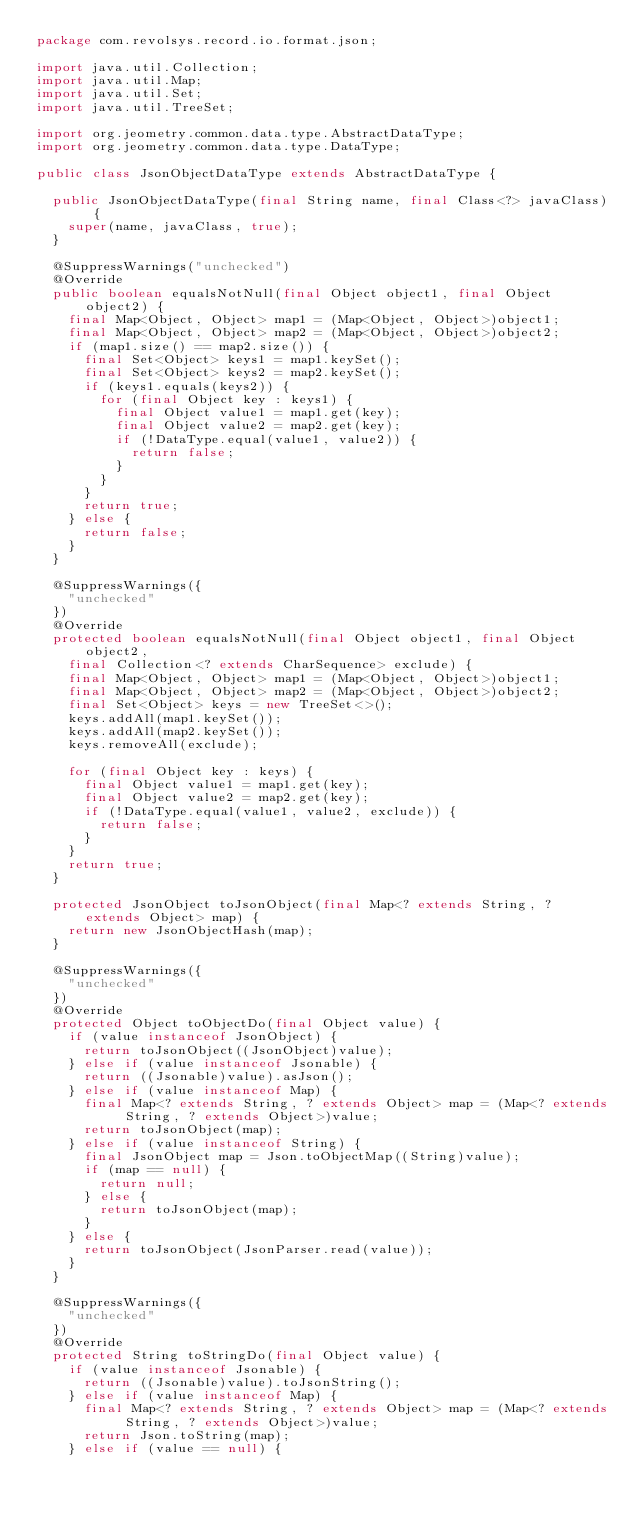Convert code to text. <code><loc_0><loc_0><loc_500><loc_500><_Java_>package com.revolsys.record.io.format.json;

import java.util.Collection;
import java.util.Map;
import java.util.Set;
import java.util.TreeSet;

import org.jeometry.common.data.type.AbstractDataType;
import org.jeometry.common.data.type.DataType;

public class JsonObjectDataType extends AbstractDataType {

  public JsonObjectDataType(final String name, final Class<?> javaClass) {
    super(name, javaClass, true);
  }

  @SuppressWarnings("unchecked")
  @Override
  public boolean equalsNotNull(final Object object1, final Object object2) {
    final Map<Object, Object> map1 = (Map<Object, Object>)object1;
    final Map<Object, Object> map2 = (Map<Object, Object>)object2;
    if (map1.size() == map2.size()) {
      final Set<Object> keys1 = map1.keySet();
      final Set<Object> keys2 = map2.keySet();
      if (keys1.equals(keys2)) {
        for (final Object key : keys1) {
          final Object value1 = map1.get(key);
          final Object value2 = map2.get(key);
          if (!DataType.equal(value1, value2)) {
            return false;
          }
        }
      }
      return true;
    } else {
      return false;
    }
  }

  @SuppressWarnings({
    "unchecked"
  })
  @Override
  protected boolean equalsNotNull(final Object object1, final Object object2,
    final Collection<? extends CharSequence> exclude) {
    final Map<Object, Object> map1 = (Map<Object, Object>)object1;
    final Map<Object, Object> map2 = (Map<Object, Object>)object2;
    final Set<Object> keys = new TreeSet<>();
    keys.addAll(map1.keySet());
    keys.addAll(map2.keySet());
    keys.removeAll(exclude);

    for (final Object key : keys) {
      final Object value1 = map1.get(key);
      final Object value2 = map2.get(key);
      if (!DataType.equal(value1, value2, exclude)) {
        return false;
      }
    }
    return true;
  }

  protected JsonObject toJsonObject(final Map<? extends String, ? extends Object> map) {
    return new JsonObjectHash(map);
  }

  @SuppressWarnings({
    "unchecked"
  })
  @Override
  protected Object toObjectDo(final Object value) {
    if (value instanceof JsonObject) {
      return toJsonObject((JsonObject)value);
    } else if (value instanceof Jsonable) {
      return ((Jsonable)value).asJson();
    } else if (value instanceof Map) {
      final Map<? extends String, ? extends Object> map = (Map<? extends String, ? extends Object>)value;
      return toJsonObject(map);
    } else if (value instanceof String) {
      final JsonObject map = Json.toObjectMap((String)value);
      if (map == null) {
        return null;
      } else {
        return toJsonObject(map);
      }
    } else {
      return toJsonObject(JsonParser.read(value));
    }
  }

  @SuppressWarnings({
    "unchecked"
  })
  @Override
  protected String toStringDo(final Object value) {
    if (value instanceof Jsonable) {
      return ((Jsonable)value).toJsonString();
    } else if (value instanceof Map) {
      final Map<? extends String, ? extends Object> map = (Map<? extends String, ? extends Object>)value;
      return Json.toString(map);
    } else if (value == null) {</code> 